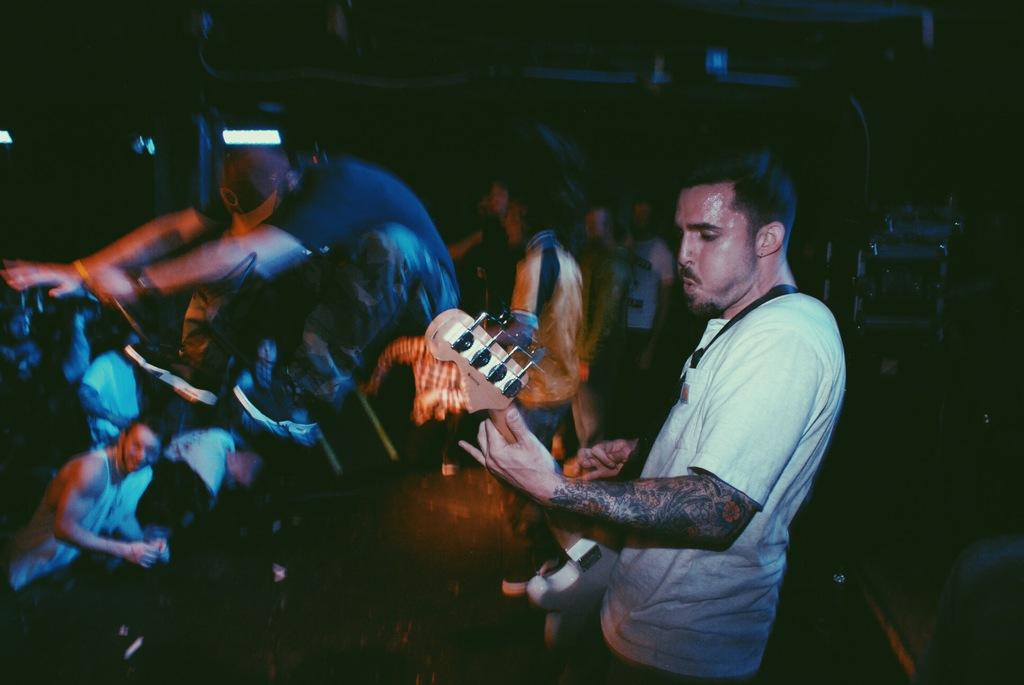What is the man in the image holding? The man is holding a guitar. Can you describe the setting of the image? The image features a man holding a guitar, with many people in the background. What type of ship can be seen in the background of the image? There is no ship present in the image; it features a man holding a guitar and many people in the background. What is the man in the image doing with his mouth? The provided facts do not mention anything about the man's mouth, so it cannot be determined from the image. 